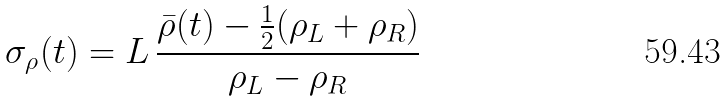<formula> <loc_0><loc_0><loc_500><loc_500>\sigma _ { \rho } ( t ) = L \, \frac { \bar { \rho } ( t ) - \frac { 1 } { 2 } ( \rho _ { L } + \rho _ { R } ) } { \rho _ { L } - \rho _ { R } }</formula> 